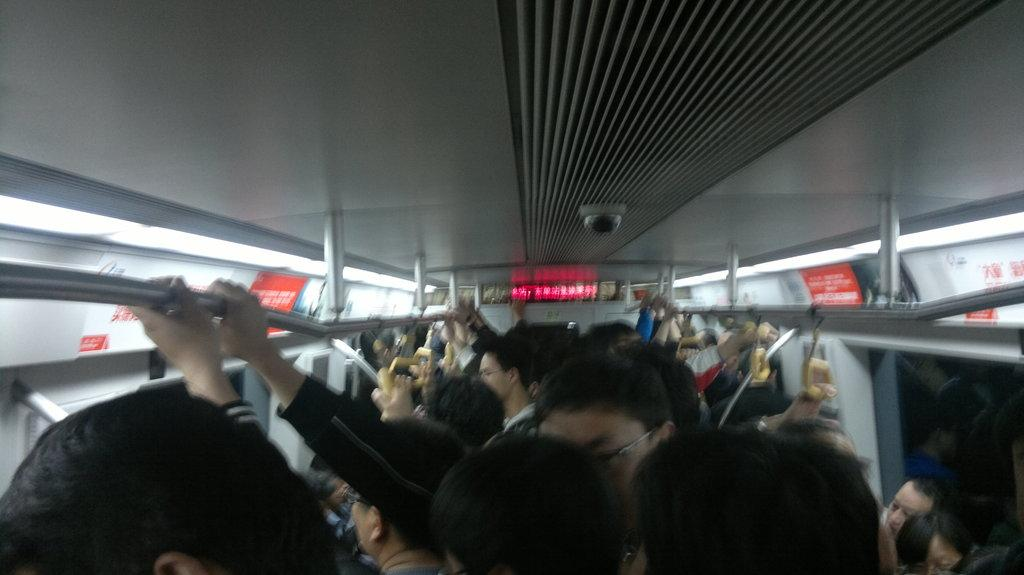What type of setting is depicted in the image? The image is an inside view of a vehicle. What are the people in the image doing? The people in the image are holding hangers and rods. What can be seen in the background of the image? There are boards and lights in the background of the image. What part of the vehicle is visible in the image? There is a roof visible in the image. How much tax is being paid in the image? There is no indication of tax being paid in the image. --- Facts: 1. There is a person in the image. 2. The person is wearing a hat. 3. The person is holding a book. 4. The person is standing in front of a bookshelf. 5. The bookshelf is filled with books. Absurd Topics: elephant, bicycle Conversation: Who or what is present in the image? There is a person in the image. What is the person wearing in the image? The person is wearing a hat. What is the person holding in the image? The person is holding a book. What is the person standing in front of in the image? The person is standing in front of a bookshelf. What can be seen on the bookshelf in the image? The bookshelf is filled with books. Reasoning: Let's think step by step in order to produce the conversation. We start by identifying the main subject of the image, which is the person. Next, we describe specific details about the person, such as the hat they are wearing and the book they are holding. Then, we observe the background of the image, mentioning that the person is standing in front of a bookshelf. Finally, we describe what can be seen on the bookshelf, noting that it is filled with books. Absurd Question/Answer: How many bicycles can be seen in the image? There are no bicycles present in the image. 